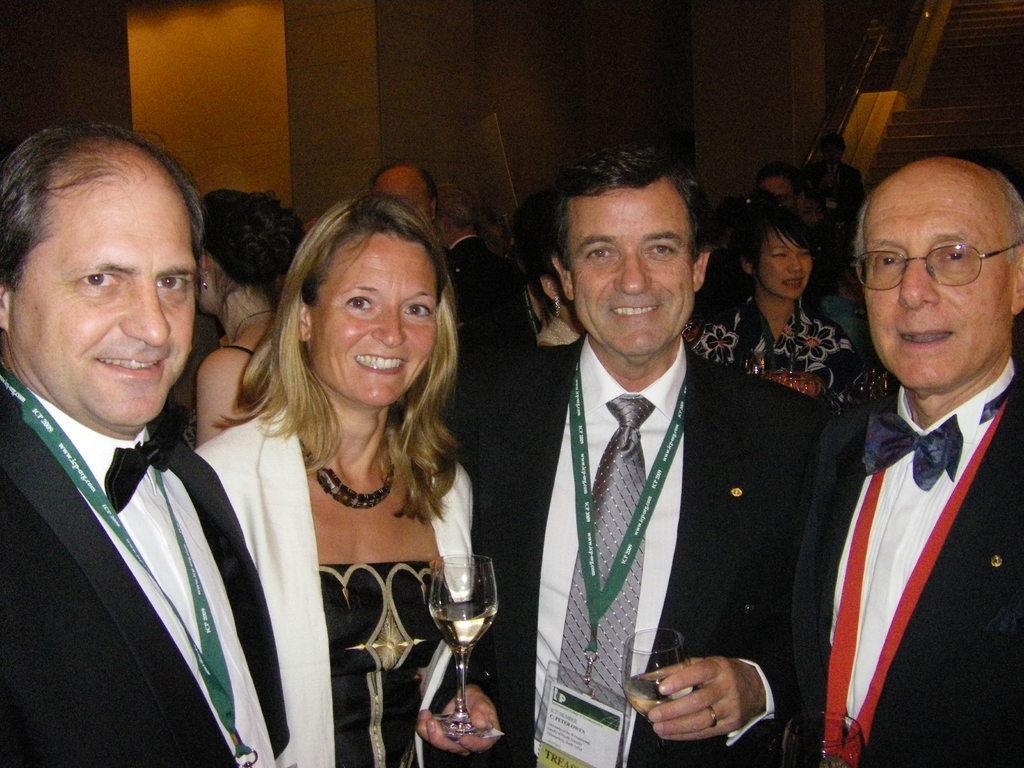Describe this image in one or two sentences. In this image, we can see people standing and smiling and some of them are holding glasses in their hands and some are wearing id cards. In the background, we can see stairs and some other people standing and there is a wall. 